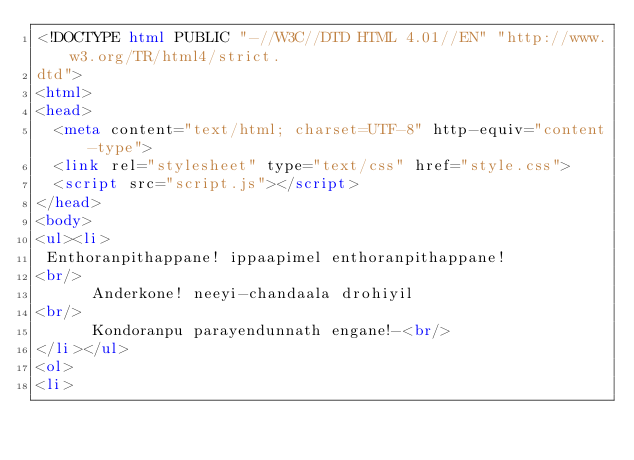Convert code to text. <code><loc_0><loc_0><loc_500><loc_500><_HTML_><!DOCTYPE html PUBLIC "-//W3C//DTD HTML 4.01//EN" "http://www.w3.org/TR/html4/strict.
dtd">
<html>
<head>
  <meta content="text/html; charset=UTF-8" http-equiv="content-type">
  <link rel="stylesheet" type="text/css" href="style.css">
  <script src="script.js"></script>
</head>
<body>
<ul><li>
 Enthoranpithappane! ippaapimel enthoranpithappane!<br/>
      Anderkone! neeyi-chandaala drohiyil<br/>
      Kondoranpu parayendunnath engane!-<br/>
</li></ul>
<ol>
<li></code> 